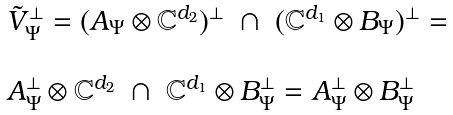Convert formula to latex. <formula><loc_0><loc_0><loc_500><loc_500>\begin{array} { l } \tilde { V } _ { \Psi } ^ { \perp } = ( A _ { \Psi } \otimes \mathbb { C } ^ { d _ { 2 } } ) ^ { \perp } \ \cap \ ( \mathbb { C } ^ { d _ { 1 } } \otimes B _ { \Psi } ) ^ { \perp } = \\ \\ A _ { \Psi } ^ { \perp } \otimes \mathbb { C } ^ { d _ { 2 } } \ \cap \ \mathbb { C } ^ { d _ { 1 } } \otimes B _ { \Psi } ^ { \perp } = A _ { \Psi } ^ { \perp } \otimes B _ { \Psi } ^ { \perp } \end{array}</formula> 